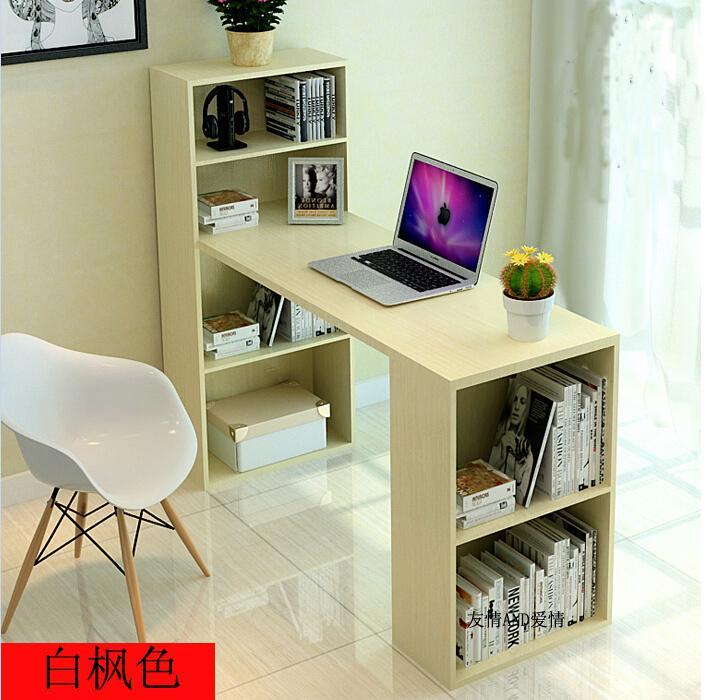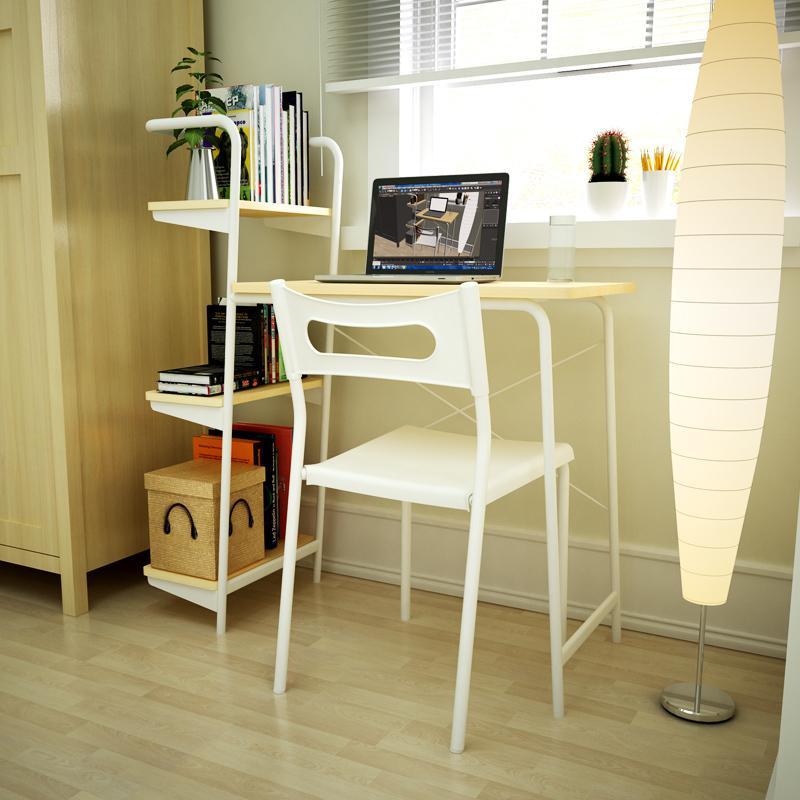The first image is the image on the left, the second image is the image on the right. Considering the images on both sides, is "There is a total of 1 flower-less, green, leafy plant sitting to the right of a laptop screen." valid? Answer yes or no. No. 